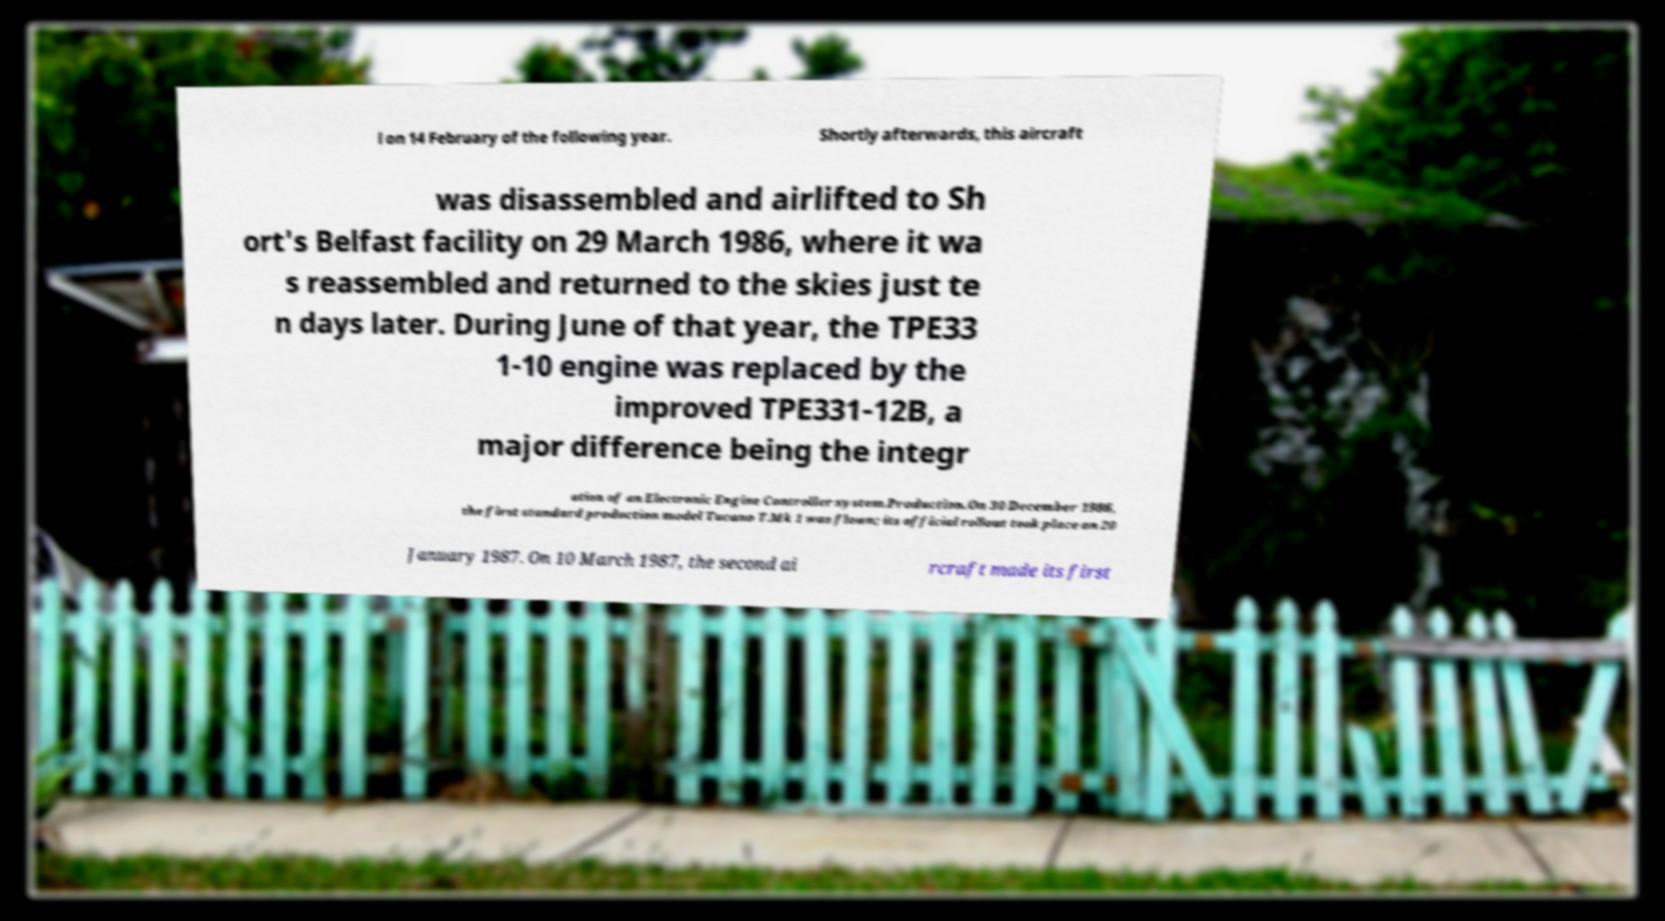Can you read and provide the text displayed in the image?This photo seems to have some interesting text. Can you extract and type it out for me? l on 14 February of the following year. Shortly afterwards, this aircraft was disassembled and airlifted to Sh ort's Belfast facility on 29 March 1986, where it wa s reassembled and returned to the skies just te n days later. During June of that year, the TPE33 1-10 engine was replaced by the improved TPE331-12B, a major difference being the integr ation of an Electronic Engine Controller system.Production.On 30 December 1986, the first standard production model Tucano T.Mk 1 was flown; its official rollout took place on 20 January 1987. On 10 March 1987, the second ai rcraft made its first 